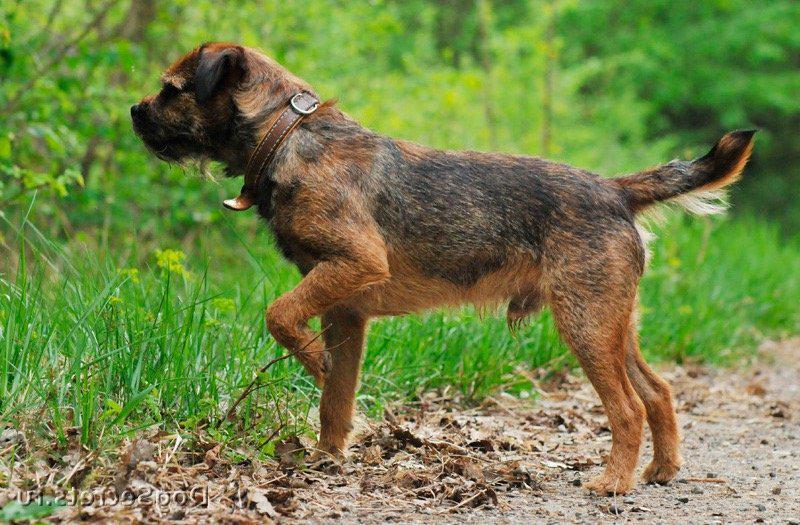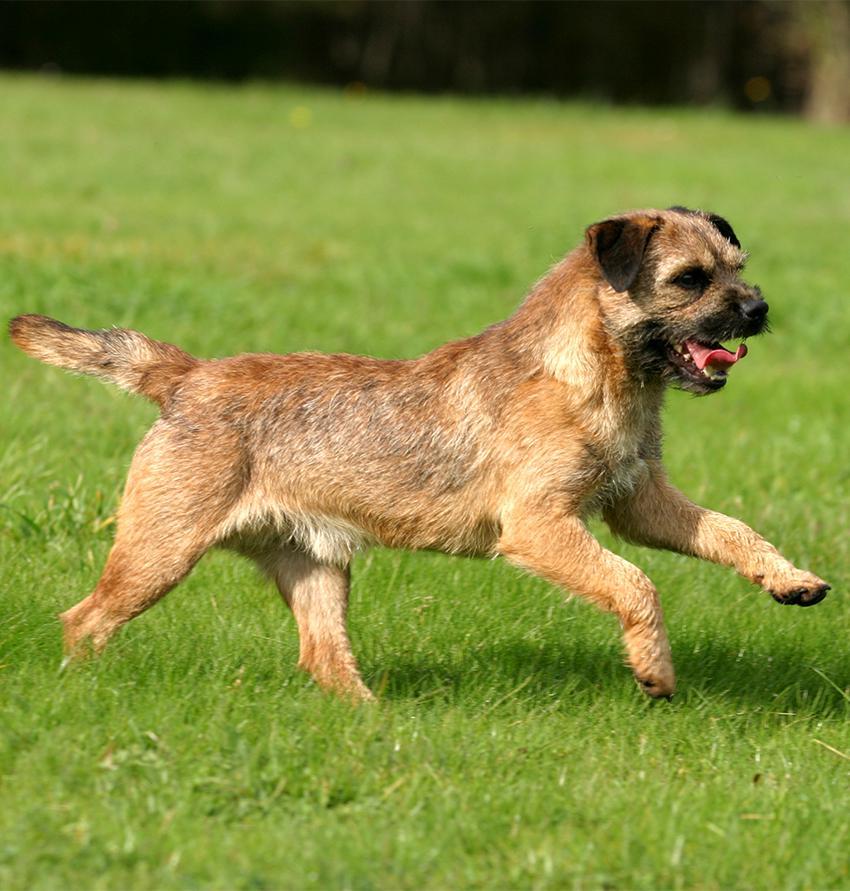The first image is the image on the left, the second image is the image on the right. For the images displayed, is the sentence "The right image contains one dog standing with its head and body in profile turned leftward, with all paws on the ground, its mouth closed, and its tail straight and extended." factually correct? Answer yes or no. No. 